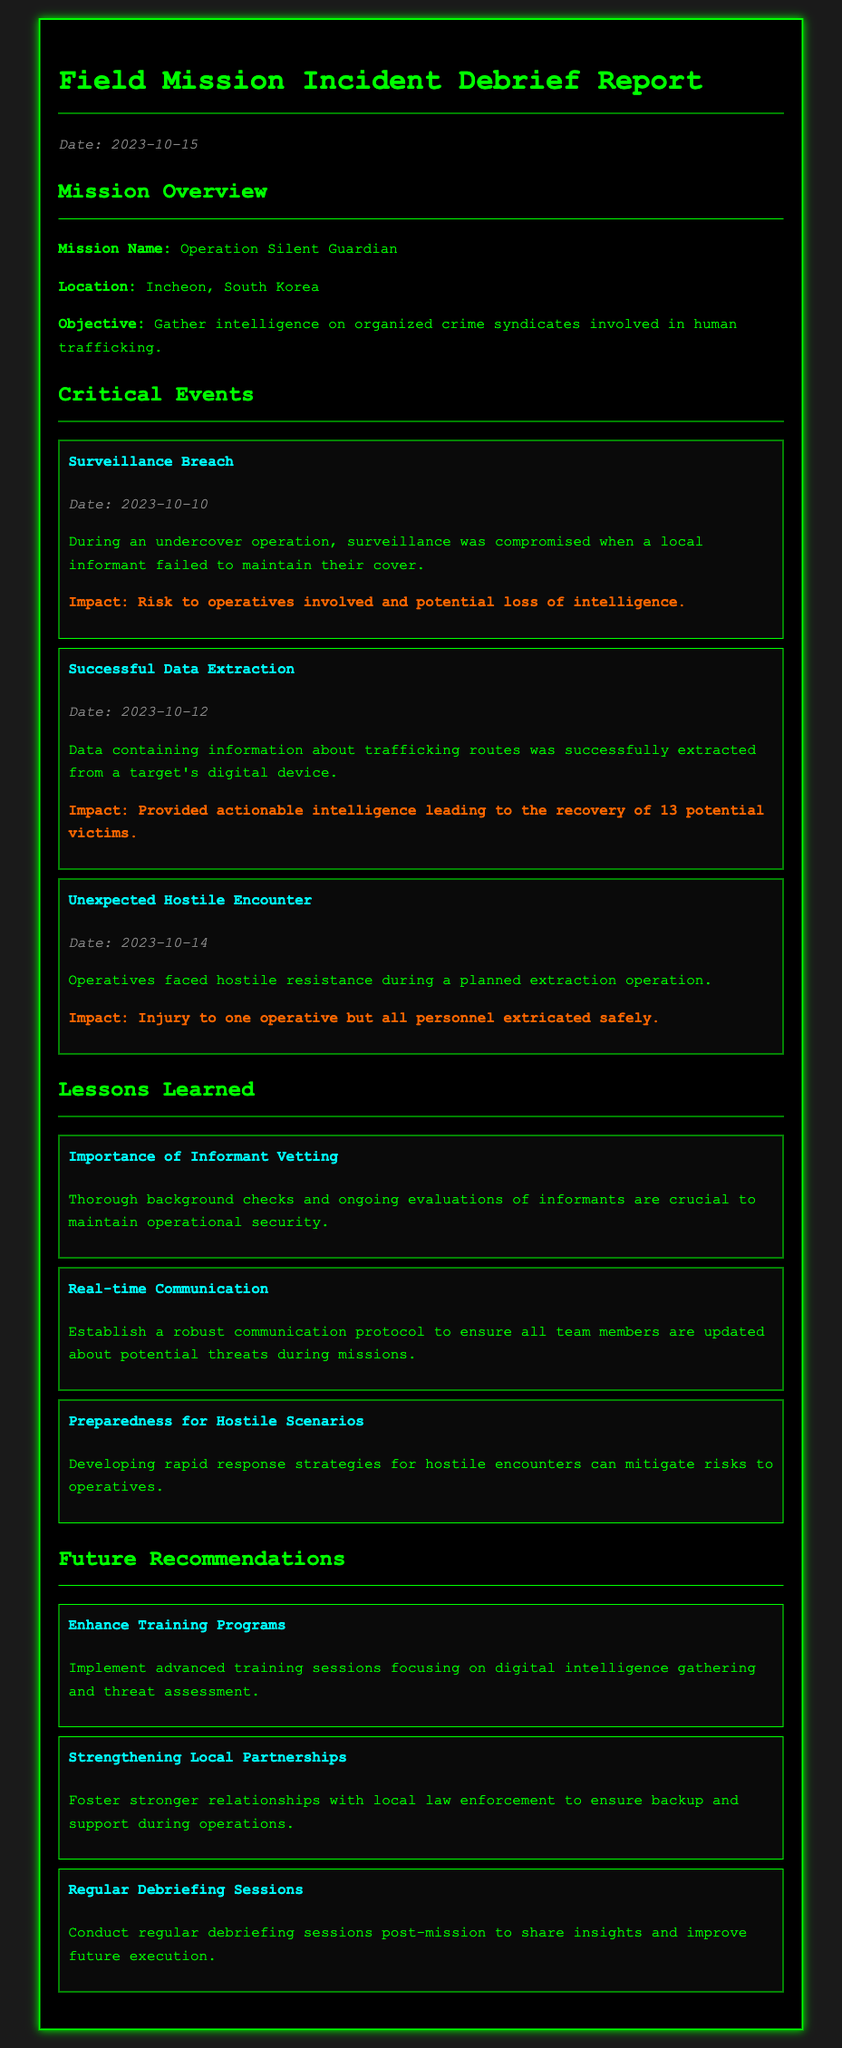What is the mission name? The mission name is explicitly stated in the document as "Operation Silent Guardian."
Answer: Operation Silent Guardian What is the location of the mission? The location mentioned in the report is Incheon, South Korea.
Answer: Incheon, South Korea What date did the surveillance breach occur? The date of the surveillance breach is provided as October 10, 2023.
Answer: 2023-10-10 How many potential victims were recovered following the data extraction? The report notes that 13 potential victims were recovered as a result of the successful data extraction.
Answer: 13 What is one lesson learned regarding informants? One lesson learned indicates the importance of conducting thorough background checks and ongoing evaluations of informants.
Answer: Importance of Informant Vetting What is the impact of the unexpected hostile encounter? According to the report, the impact of the encounter was injury to one operative but all personnel extricated safely.
Answer: Injury to one operative but all personnel extricated safely What recommendation is made for future training programs? The recommendation suggests implementing advanced training sessions focusing on digital intelligence gathering and threat assessment.
Answer: Enhance Training Programs What was the date of the successful data extraction? The successful data extraction took place on October 12, 2023.
Answer: 2023-10-12 